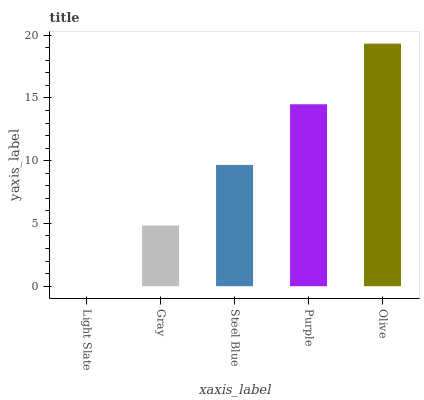Is Light Slate the minimum?
Answer yes or no. Yes. Is Olive the maximum?
Answer yes or no. Yes. Is Gray the minimum?
Answer yes or no. No. Is Gray the maximum?
Answer yes or no. No. Is Gray greater than Light Slate?
Answer yes or no. Yes. Is Light Slate less than Gray?
Answer yes or no. Yes. Is Light Slate greater than Gray?
Answer yes or no. No. Is Gray less than Light Slate?
Answer yes or no. No. Is Steel Blue the high median?
Answer yes or no. Yes. Is Steel Blue the low median?
Answer yes or no. Yes. Is Light Slate the high median?
Answer yes or no. No. Is Light Slate the low median?
Answer yes or no. No. 